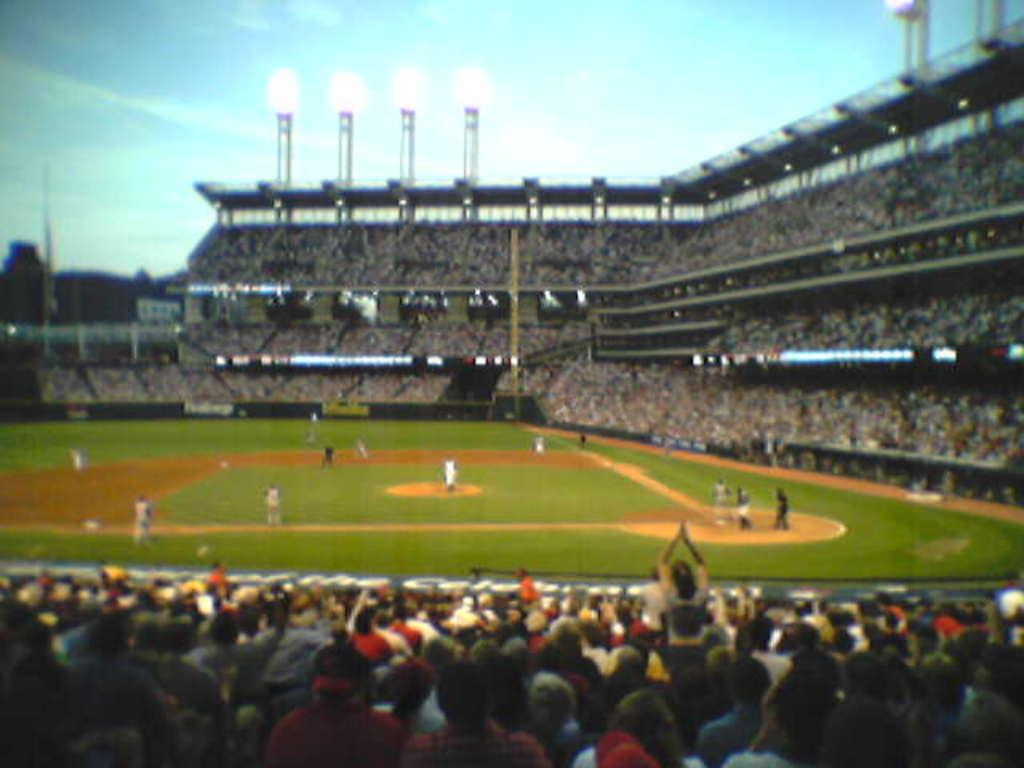What type of venue is depicted in the image? The image shows a stadium. What activity is taking place on the field? There are players playing on the green field. Who is watching the game? There is an audience seated and watching the game. What can be seen in the image that provides illumination? There are lights visible in the image. How would you describe the weather based on the sky in the image? The sky is blue and cloudy, suggesting a partly cloudy day. What language are the players using to communicate with each other during the game? The image does not provide information about the language being spoken by the players. How many cast members are visible in the image? There are no cast members present in the image; it shows a stadium with players and an audience. 